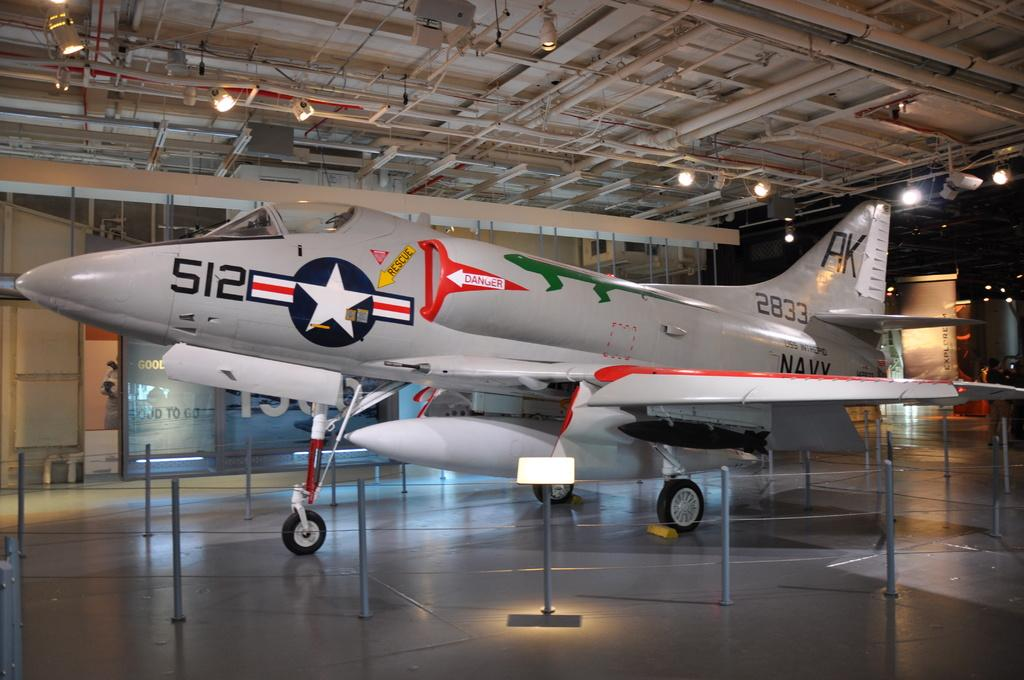<image>
Share a concise interpretation of the image provided. A grey fighter jet says 2833 and is on display in a hanger. 